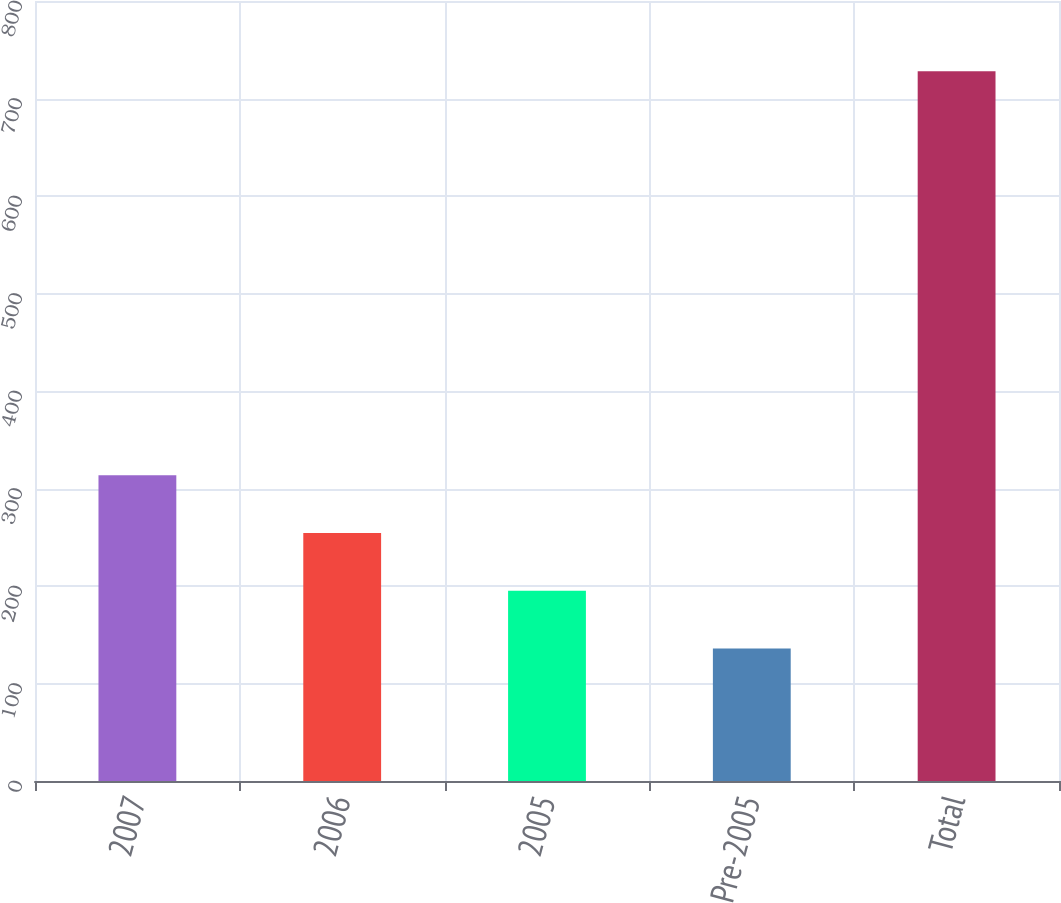<chart> <loc_0><loc_0><loc_500><loc_500><bar_chart><fcel>2007<fcel>2006<fcel>2005<fcel>Pre-2005<fcel>Total<nl><fcel>313.6<fcel>254.4<fcel>195.2<fcel>136<fcel>728<nl></chart> 